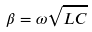<formula> <loc_0><loc_0><loc_500><loc_500>\beta = \omega \sqrt { L C }</formula> 